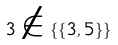Convert formula to latex. <formula><loc_0><loc_0><loc_500><loc_500>3 \notin \{ \{ 3 , 5 \} \}</formula> 